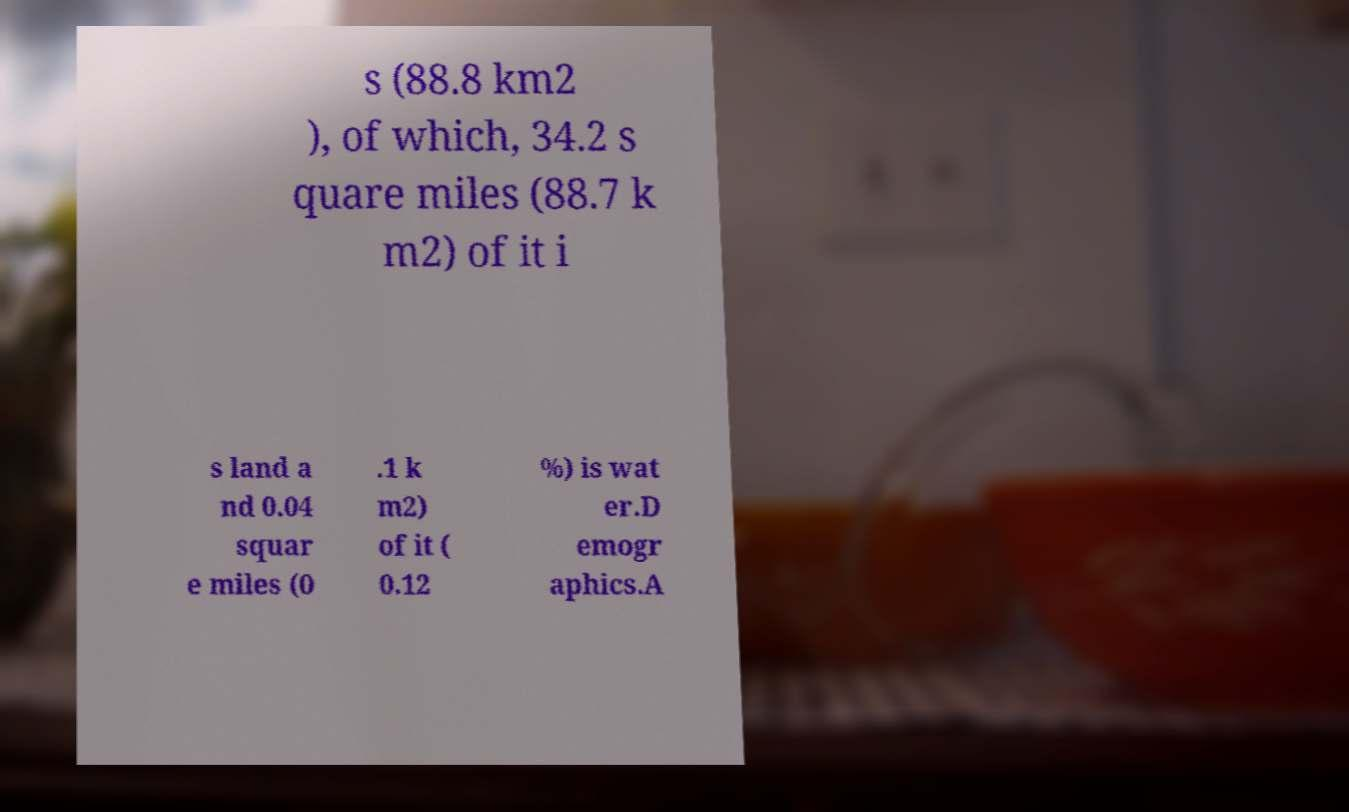Could you extract and type out the text from this image? s (88.8 km2 ), of which, 34.2 s quare miles (88.7 k m2) of it i s land a nd 0.04 squar e miles (0 .1 k m2) of it ( 0.12 %) is wat er.D emogr aphics.A 